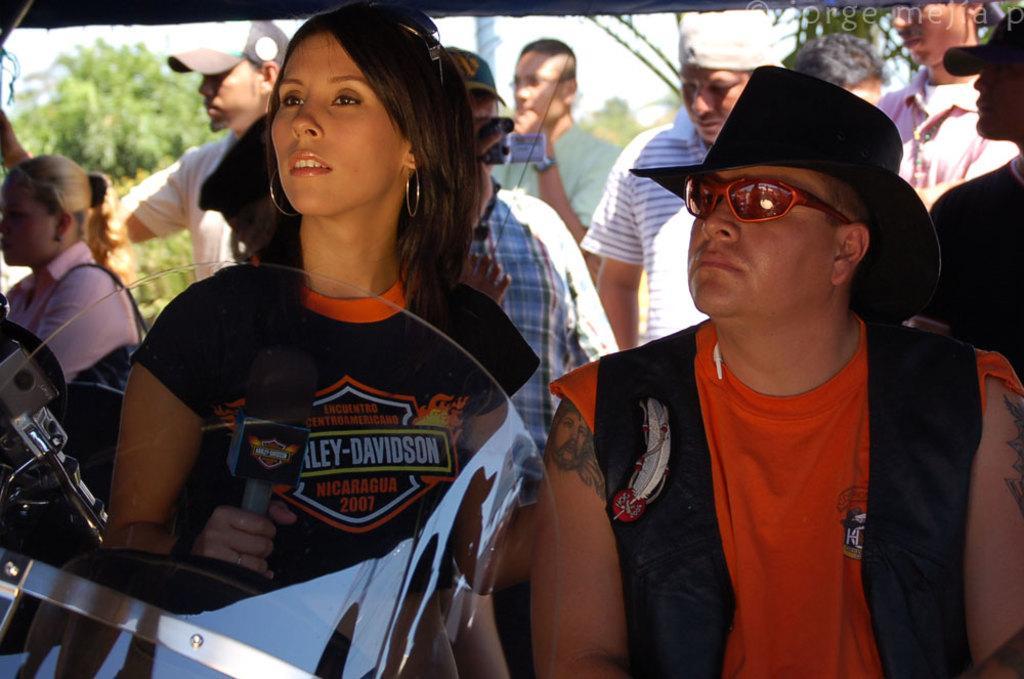Describe this image in one or two sentences. In this image I can see number of people and I can see most of them are wearing caps. Here I can see she is holding a mic and on her dress I can see something is written. Here I can see he is wearing shades and in background I can see few trees. I can also see this image is little bit blurry from background. 